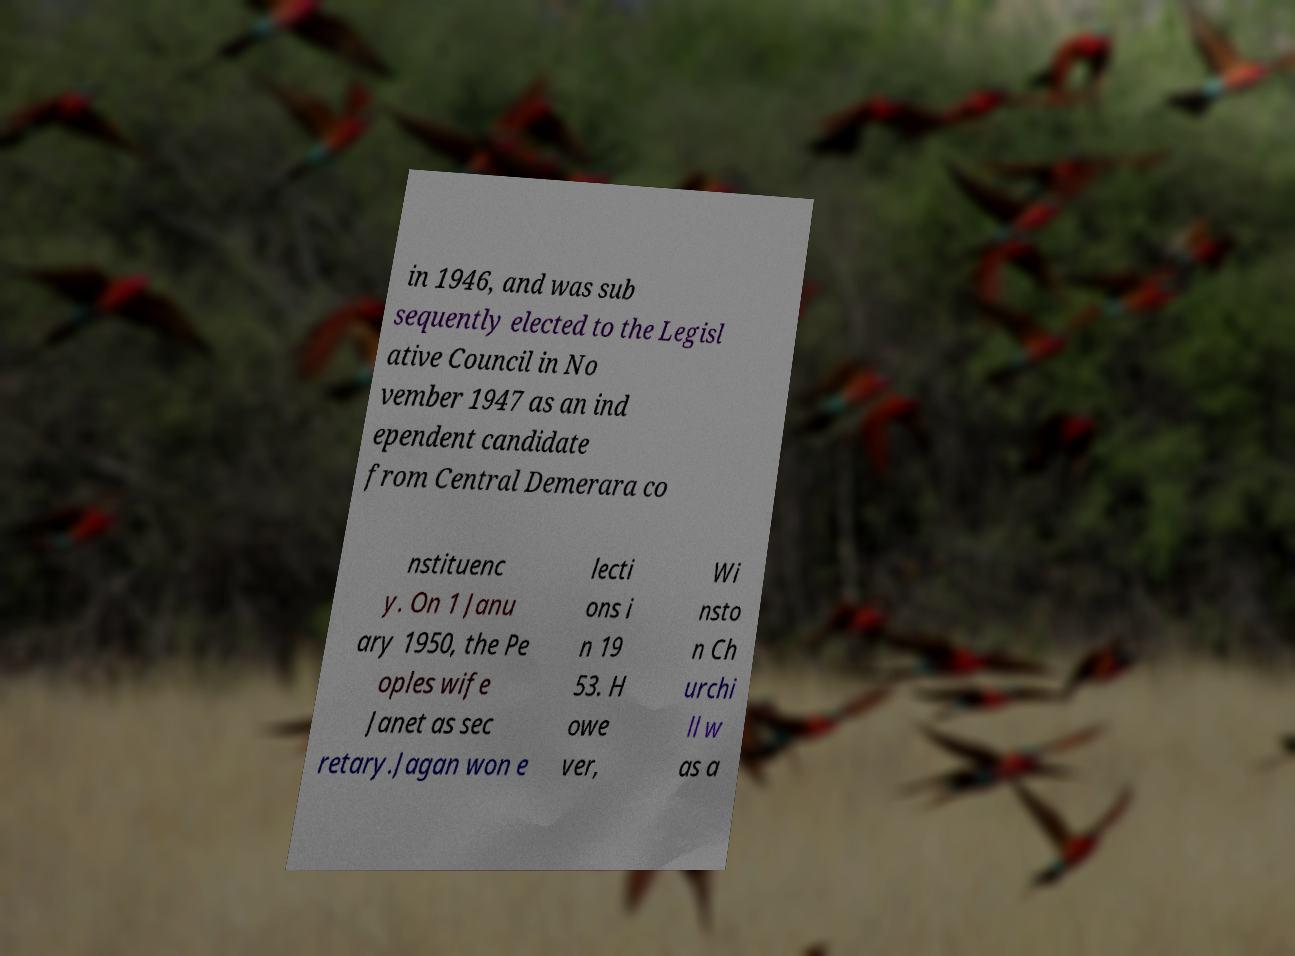Could you extract and type out the text from this image? in 1946, and was sub sequently elected to the Legisl ative Council in No vember 1947 as an ind ependent candidate from Central Demerara co nstituenc y. On 1 Janu ary 1950, the Pe oples wife Janet as sec retary.Jagan won e lecti ons i n 19 53. H owe ver, Wi nsto n Ch urchi ll w as a 